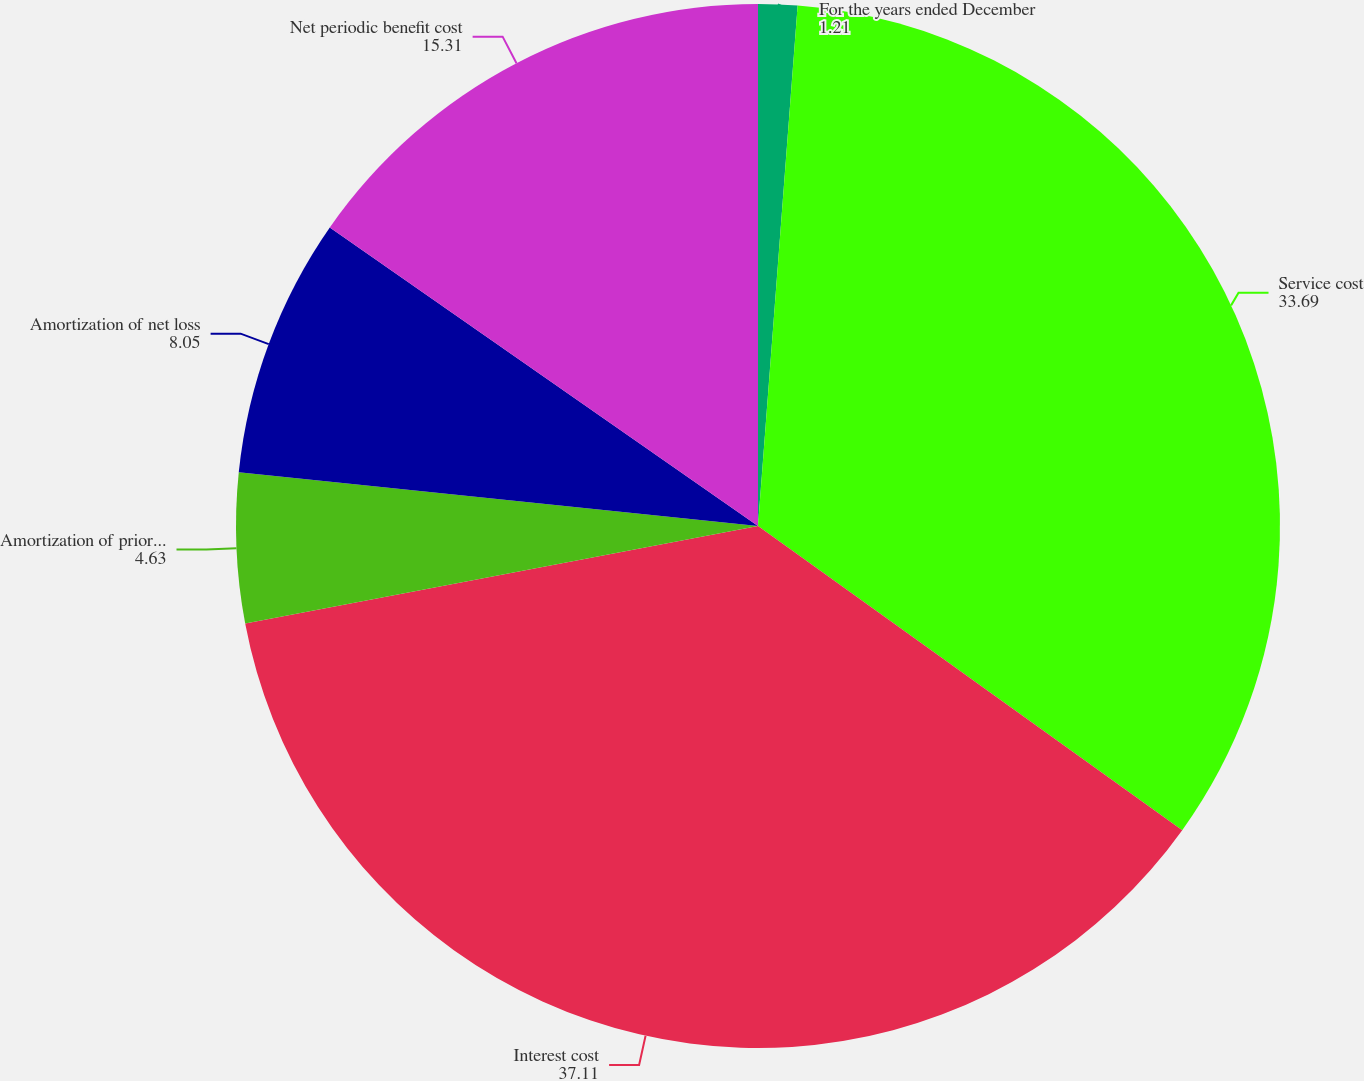<chart> <loc_0><loc_0><loc_500><loc_500><pie_chart><fcel>For the years ended December<fcel>Service cost<fcel>Interest cost<fcel>Amortization of prior service<fcel>Amortization of net loss<fcel>Net periodic benefit cost<nl><fcel>1.21%<fcel>33.69%<fcel>37.11%<fcel>4.63%<fcel>8.05%<fcel>15.31%<nl></chart> 